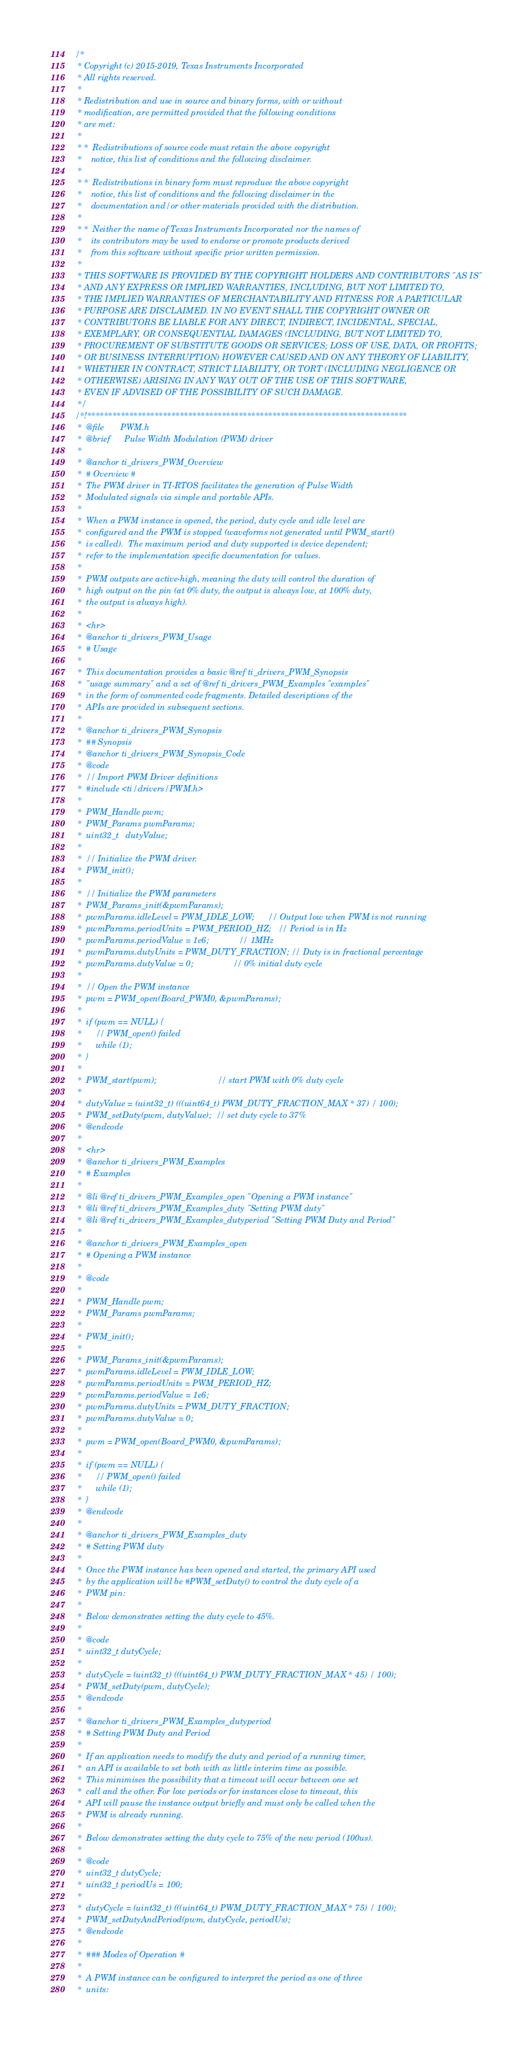Convert code to text. <code><loc_0><loc_0><loc_500><loc_500><_C_>/*
 * Copyright (c) 2015-2019, Texas Instruments Incorporated
 * All rights reserved.
 *
 * Redistribution and use in source and binary forms, with or without
 * modification, are permitted provided that the following conditions
 * are met:
 *
 * *  Redistributions of source code must retain the above copyright
 *    notice, this list of conditions and the following disclaimer.
 *
 * *  Redistributions in binary form must reproduce the above copyright
 *    notice, this list of conditions and the following disclaimer in the
 *    documentation and/or other materials provided with the distribution.
 *
 * *  Neither the name of Texas Instruments Incorporated nor the names of
 *    its contributors may be used to endorse or promote products derived
 *    from this software without specific prior written permission.
 *
 * THIS SOFTWARE IS PROVIDED BY THE COPYRIGHT HOLDERS AND CONTRIBUTORS "AS IS"
 * AND ANY EXPRESS OR IMPLIED WARRANTIES, INCLUDING, BUT NOT LIMITED TO,
 * THE IMPLIED WARRANTIES OF MERCHANTABILITY AND FITNESS FOR A PARTICULAR
 * PURPOSE ARE DISCLAIMED. IN NO EVENT SHALL THE COPYRIGHT OWNER OR
 * CONTRIBUTORS BE LIABLE FOR ANY DIRECT, INDIRECT, INCIDENTAL, SPECIAL,
 * EXEMPLARY, OR CONSEQUENTIAL DAMAGES (INCLUDING, BUT NOT LIMITED TO,
 * PROCUREMENT OF SUBSTITUTE GOODS OR SERVICES; LOSS OF USE, DATA, OR PROFITS;
 * OR BUSINESS INTERRUPTION) HOWEVER CAUSED AND ON ANY THEORY OF LIABILITY,
 * WHETHER IN CONTRACT, STRICT LIABILITY, OR TORT (INCLUDING NEGLIGENCE OR
 * OTHERWISE) ARISING IN ANY WAY OUT OF THE USE OF THIS SOFTWARE,
 * EVEN IF ADVISED OF THE POSSIBILITY OF SUCH DAMAGE.
 */
/*!****************************************************************************
 *  @file       PWM.h
 *  @brief      Pulse Width Modulation (PWM) driver
 *
 *  @anchor ti_drivers_PWM_Overview
 *  # Overview #
 *  The PWM driver in TI-RTOS facilitates the generation of Pulse Width
 *  Modulated signals via simple and portable APIs.
 *
 *  When a PWM instance is opened, the period, duty cycle and idle level are
 *  configured and the PWM is stopped (waveforms not generated until PWM_start()
 *  is called).  The maximum period and duty supported is device dependent;
 *  refer to the implementation specific documentation for values.
 *
 *  PWM outputs are active-high, meaning the duty will control the duration of
 *  high output on the pin (at 0% duty, the output is always low, at 100% duty,
 *  the output is always high).
 *
 *  <hr>
 *  @anchor ti_drivers_PWM_Usage
 *  # Usage
 *  
 *  This documentation provides a basic @ref ti_drivers_PWM_Synopsis
 *  "usage summary" and a set of @ref ti_drivers_PWM_Examples "examples"
 *  in the form of commented code fragments. Detailed descriptions of the
 *  APIs are provided in subsequent sections.
 *
 *  @anchor ti_drivers_PWM_Synopsis
 *  ## Synopsis
 *  @anchor ti_drivers_PWM_Synopsis_Code
 *  @code
 *  // Import PWM Driver definitions
 *  #include <ti/drivers/PWM.h>
 *
 *  PWM_Handle pwm;
 *  PWM_Params pwmParams;
 *  uint32_t   dutyValue;
 *
 *  // Initialize the PWM driver.
 *  PWM_init();
 *
 *  // Initialize the PWM parameters
 *  PWM_Params_init(&pwmParams);
 *  pwmParams.idleLevel = PWM_IDLE_LOW;      // Output low when PWM is not running
 *  pwmParams.periodUnits = PWM_PERIOD_HZ;   // Period is in Hz
 *  pwmParams.periodValue = 1e6;             // 1MHz
 *  pwmParams.dutyUnits = PWM_DUTY_FRACTION; // Duty is in fractional percentage
 *  pwmParams.dutyValue = 0;                 // 0% initial duty cycle
 *
 *  // Open the PWM instance
 *  pwm = PWM_open(Board_PWM0, &pwmParams);
 *
 *  if (pwm == NULL) {
 *      // PWM_open() failed
 *      while (1);
 *  }
 *
 *  PWM_start(pwm);                          // start PWM with 0% duty cycle
 *
 *  dutyValue = (uint32_t) (((uint64_t) PWM_DUTY_FRACTION_MAX * 37) / 100);
 *  PWM_setDuty(pwm, dutyValue);  // set duty cycle to 37%
 *  @endcode
 *  
 *  <hr>
 *  @anchor ti_drivers_PWM_Examples
 *  # Examples
 *  
 *  @li @ref ti_drivers_PWM_Examples_open "Opening a PWM instance"
 *  @li @ref ti_drivers_PWM_Examples_duty "Setting PWM duty"
 *  @li @ref ti_drivers_PWM_Examples_dutyperiod "Setting PWM Duty and Period"
 *
 *  @anchor ti_drivers_PWM_Examples_open
 *  # Opening a PWM instance
 *  
 *  @code
 *  
 *  PWM_Handle pwm;
 *  PWM_Params pwmParams;
 *
 *  PWM_init();
 *  
 *  PWM_Params_init(&pwmParams);
 *  pwmParams.idleLevel = PWM_IDLE_LOW;
 *  pwmParams.periodUnits = PWM_PERIOD_HZ;
 *  pwmParams.periodValue = 1e6;
 *  pwmParams.dutyUnits = PWM_DUTY_FRACTION;
 *  pwmParams.dutyValue = 0;
 *
 *  pwm = PWM_open(Board_PWM0, &pwmParams);
 *
 *  if (pwm == NULL) {
 *      // PWM_open() failed
 *      while (1);
 *  }
 *  @endcode
 *  
 *  @anchor ti_drivers_PWM_Examples_duty
 *  # Setting PWM duty
 *  
 *  Once the PWM instance has been opened and started, the primary API used
 *  by the application will be #PWM_setDuty() to control the duty cycle of a
 *  PWM pin:
 *
 *  Below demonstrates setting the duty cycle to 45%.
 *
 *  @code
 *  uint32_t dutyCycle;
 *
 *  dutyCycle = (uint32_t) (((uint64_t) PWM_DUTY_FRACTION_MAX * 45) / 100);
 *  PWM_setDuty(pwm, dutyCycle);
 *  @endcode
 *  
 *  @anchor ti_drivers_PWM_Examples_dutyperiod
 *  # Setting PWM Duty and Period
 *  
 *  If an application needs to modify the duty and period of a running timer,
 *  an API is available to set both with as little interim time as possible.
 *  This minimises the possibility that a timeout will occur between one set
 *  call and the other. For low periods or for instances close to timeout, this
 *  API will pause the instance output briefly and must only be called when the
 *  PWM is already running.
 *
 *  Below demonstrates setting the duty cycle to 75% of the new period (100us).
 *
 *  @code
 *  uint32_t dutyCycle;
 *  uint32_t periodUs = 100;
 *
 *  dutyCycle = (uint32_t) (((uint64_t) PWM_DUTY_FRACTION_MAX * 75) / 100);
 *  PWM_setDutyAndPeriod(pwm, dutyCycle, periodUs);
 *  @endcode
 *
 *  ### Modes of Operation #
 *
 *  A PWM instance can be configured to interpret the period as one of three
 *  units:</code> 